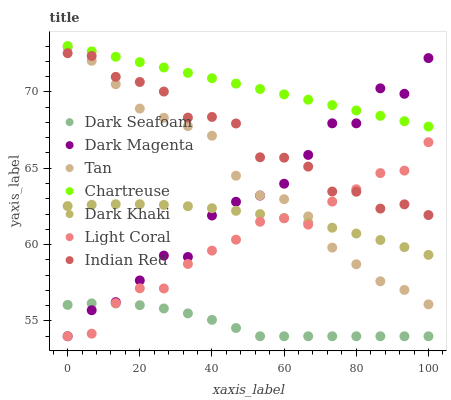Does Dark Seafoam have the minimum area under the curve?
Answer yes or no. Yes. Does Chartreuse have the maximum area under the curve?
Answer yes or no. Yes. Does Dark Magenta have the minimum area under the curve?
Answer yes or no. No. Does Dark Magenta have the maximum area under the curve?
Answer yes or no. No. Is Chartreuse the smoothest?
Answer yes or no. Yes. Is Dark Magenta the roughest?
Answer yes or no. Yes. Is Dark Magenta the smoothest?
Answer yes or no. No. Is Chartreuse the roughest?
Answer yes or no. No. Does Light Coral have the lowest value?
Answer yes or no. Yes. Does Chartreuse have the lowest value?
Answer yes or no. No. Does Chartreuse have the highest value?
Answer yes or no. Yes. Does Dark Magenta have the highest value?
Answer yes or no. No. Is Light Coral less than Chartreuse?
Answer yes or no. Yes. Is Dark Khaki greater than Dark Seafoam?
Answer yes or no. Yes. Does Light Coral intersect Tan?
Answer yes or no. Yes. Is Light Coral less than Tan?
Answer yes or no. No. Is Light Coral greater than Tan?
Answer yes or no. No. Does Light Coral intersect Chartreuse?
Answer yes or no. No. 